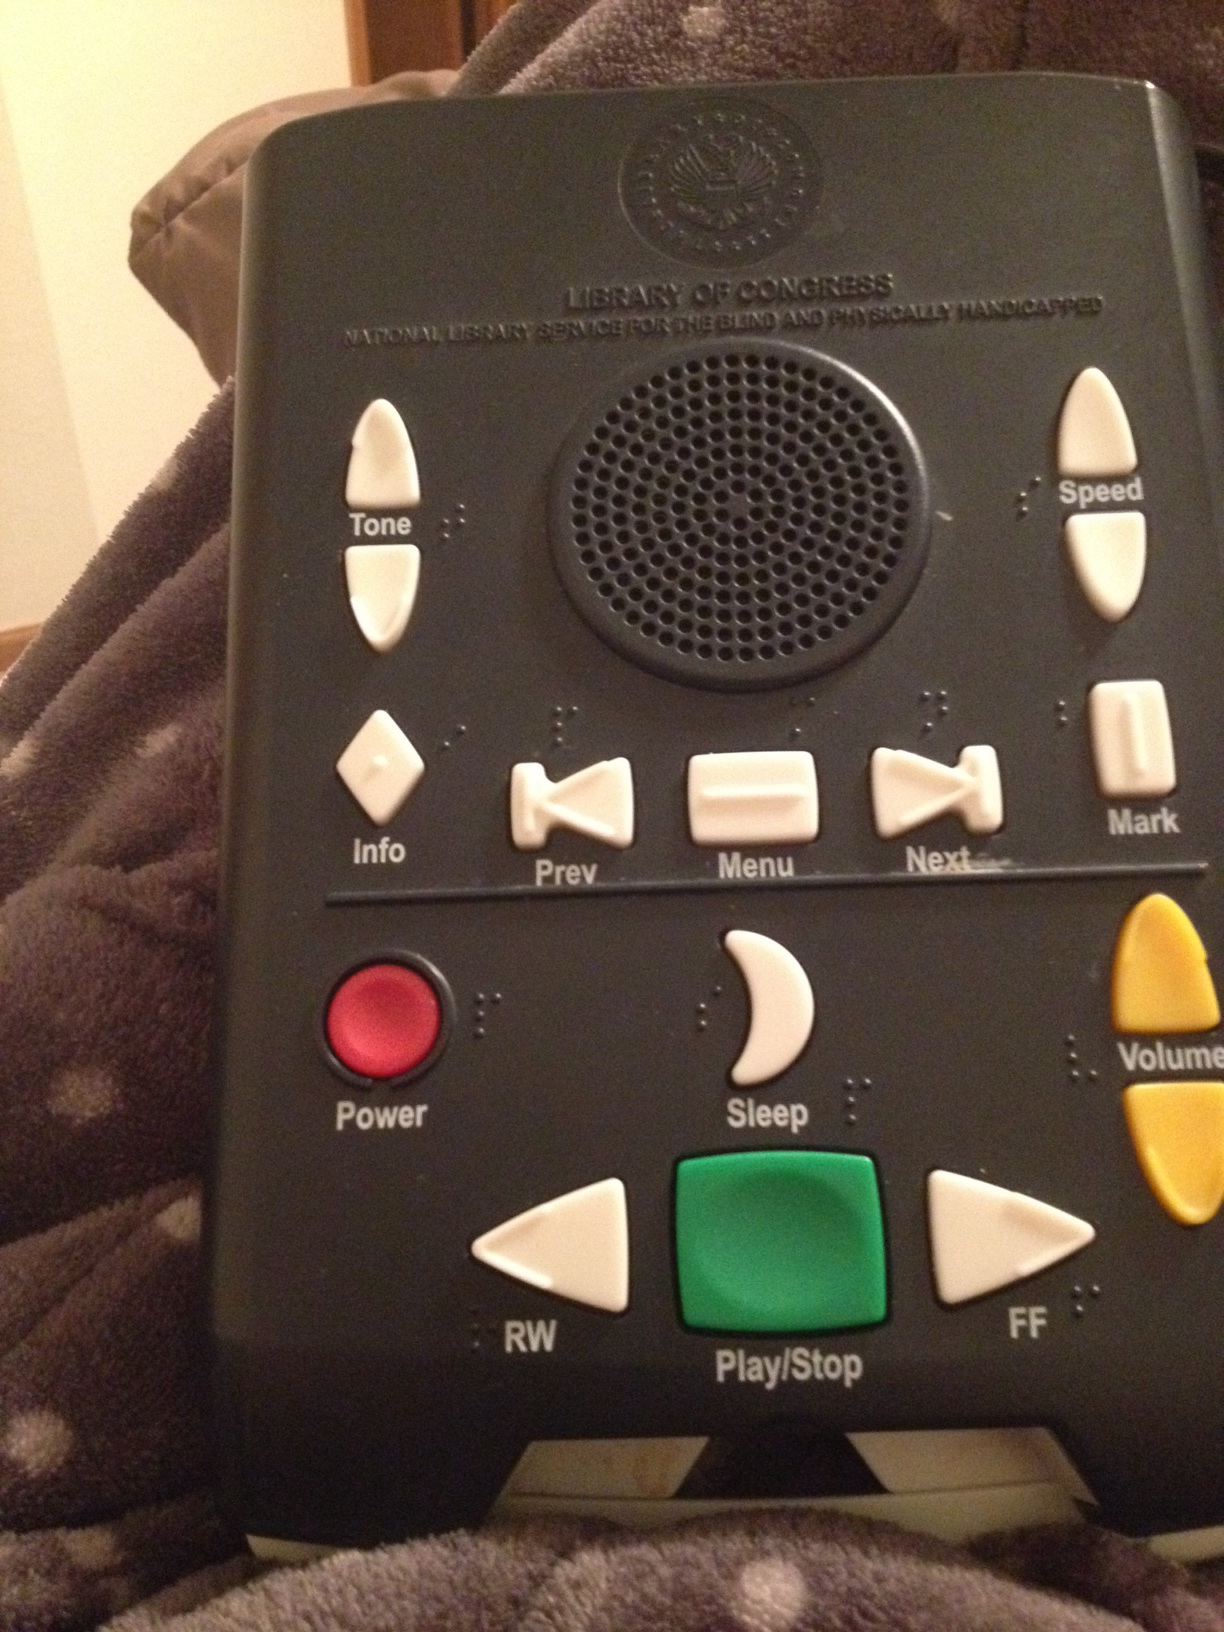Can you tell me more about the specific features of this device? Certainly! This device includes several features designed to enhance usability for visually impaired individuals. It has tactile buttons with Braille labels for controls such as 'Play/Stop', 'Rewind', and 'Fast Forward'. There are also settings for adjusting the tone and speed of audio playback, as well as buttons for navigation through menus and selection of different modes like sleep and information. 